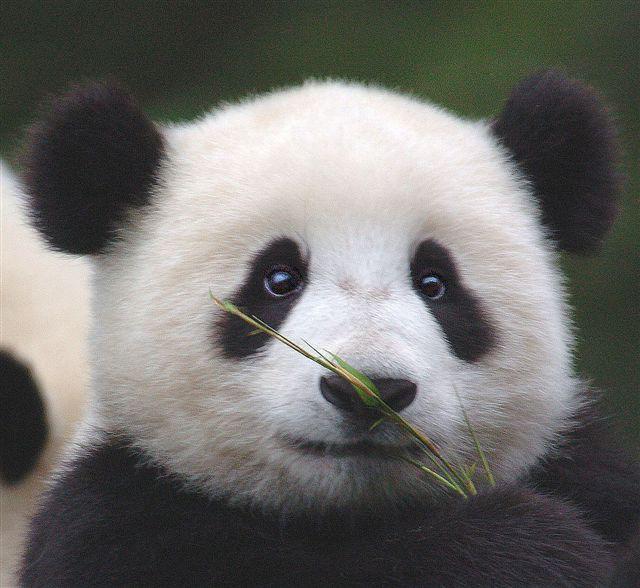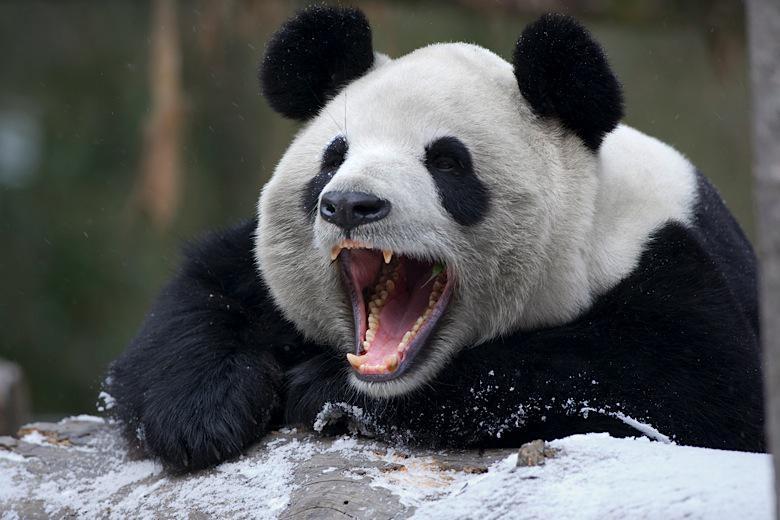The first image is the image on the left, the second image is the image on the right. Analyze the images presented: Is the assertion "In one image, a panda is sitting on something that is not wood." valid? Answer yes or no. No. The first image is the image on the left, the second image is the image on the right. For the images shown, is this caption "In one image, a panda's mouth is open" true? Answer yes or no. Yes. 